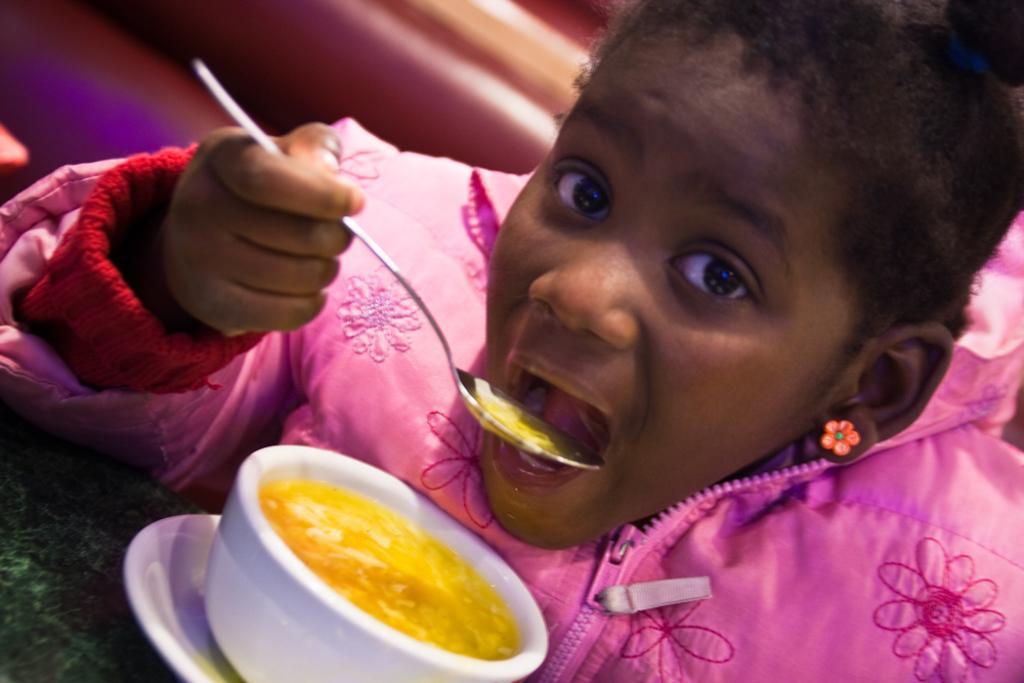In one or two sentences, can you explain what this image depicts? AS we can see in the image, there is a girl drinking soup with spoon. The cup and saucer are on table. 